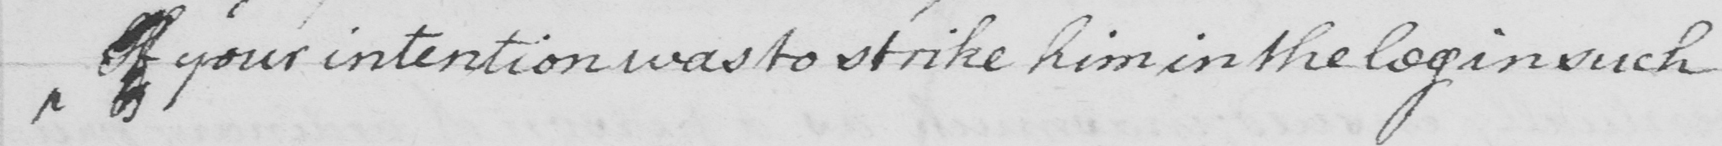What text is written in this handwritten line? If your intention was to strike him in the leg in such 